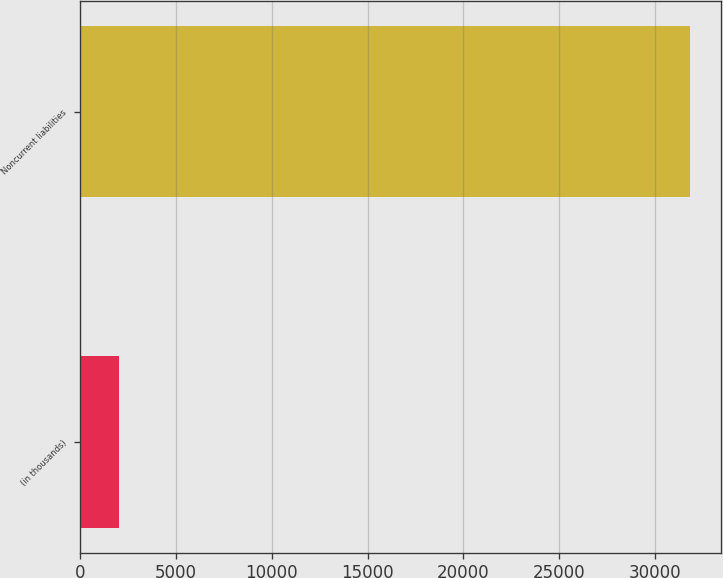Convert chart to OTSL. <chart><loc_0><loc_0><loc_500><loc_500><bar_chart><fcel>(in thousands)<fcel>Noncurrent liabilities<nl><fcel>2011<fcel>31867<nl></chart> 